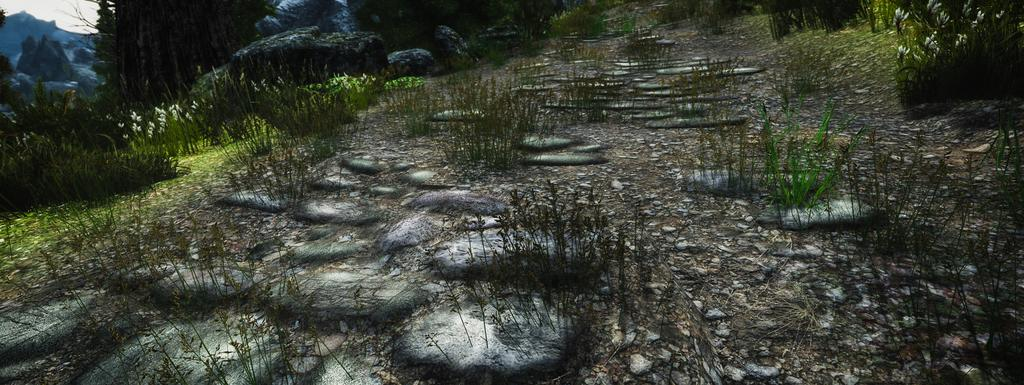What type of photograph is in the image? The image contains an animated photograph. What is the main subject of the photograph? The photograph depicts the ground. What can be found on the ground in the image? There are rocks and grass present on the ground. What is visible in the background of the image? There are mountains visible in the background of the image. What type of brick structure can be seen in the image? There is no brick structure present in the image; it features an animated photograph of the ground with rocks and grass. Can you see a coil of wire on the ground in the image? There is no coil of wire visible on the ground in the image. 